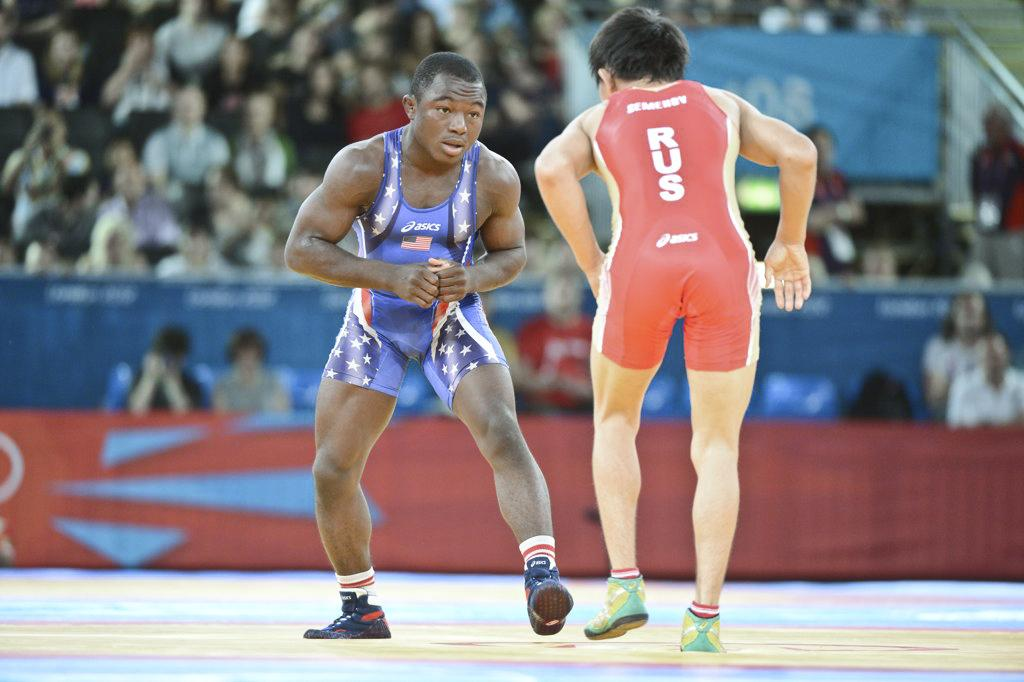<image>
Give a short and clear explanation of the subsequent image. Two wrestlers with one wearing a red outfit saying RUS. 